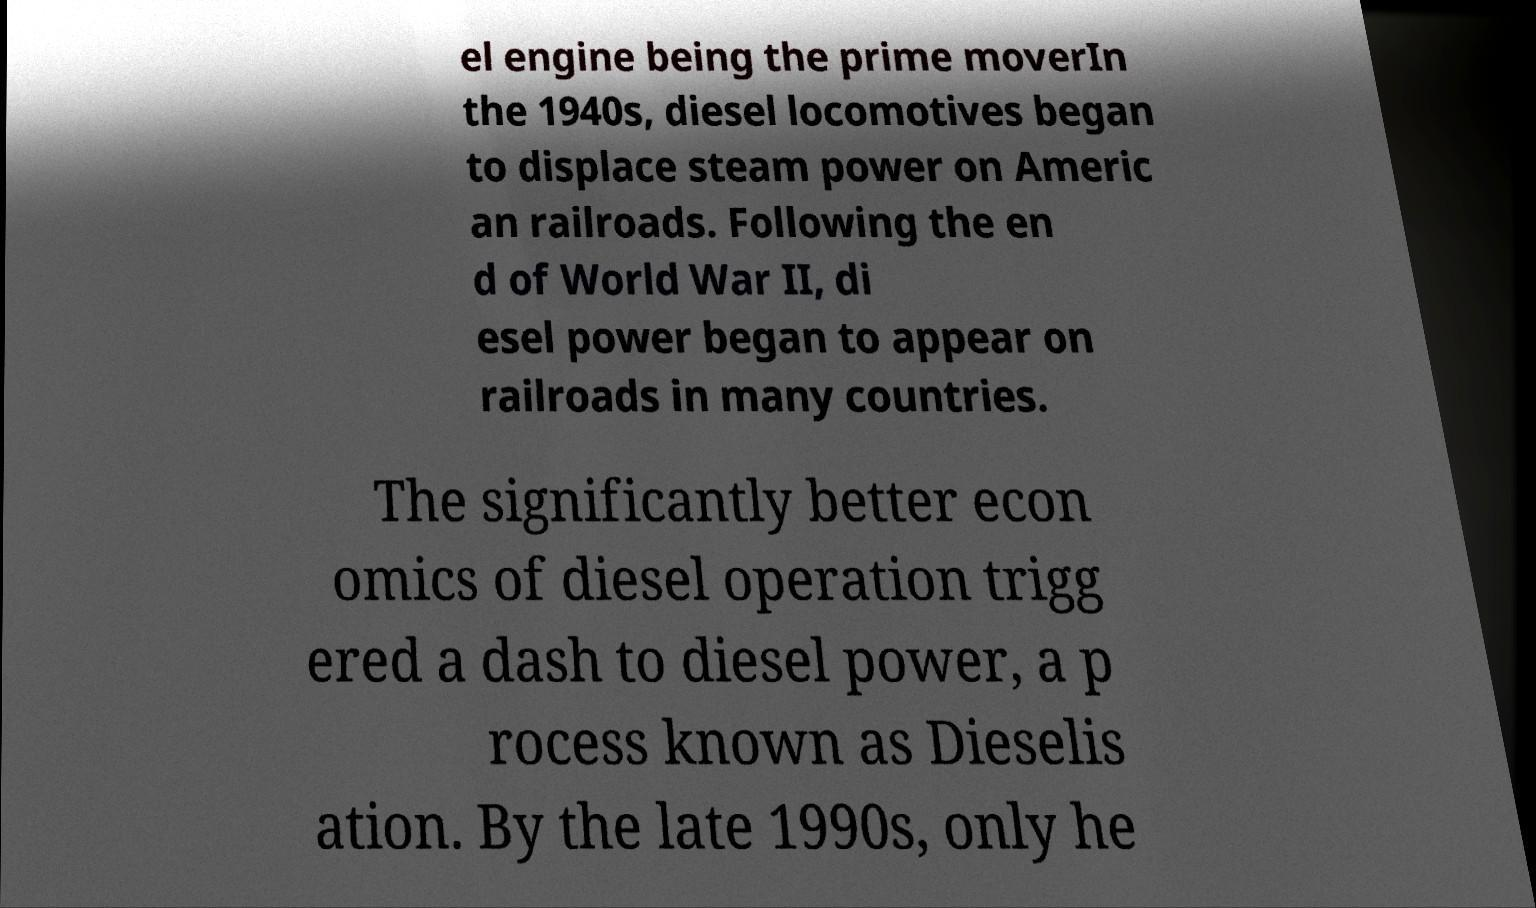I need the written content from this picture converted into text. Can you do that? el engine being the prime moverIn the 1940s, diesel locomotives began to displace steam power on Americ an railroads. Following the en d of World War II, di esel power began to appear on railroads in many countries. The significantly better econ omics of diesel operation trigg ered a dash to diesel power, a p rocess known as Dieselis ation. By the late 1990s, only he 